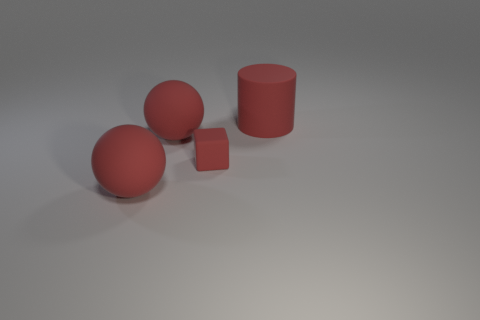Is the number of big red rubber things to the left of the small object greater than the number of red objects that are behind the large rubber cylinder?
Ensure brevity in your answer.  Yes. How many other things are there of the same material as the red cube?
Provide a succinct answer. 3. Are the big red sphere behind the tiny rubber thing and the cube made of the same material?
Your response must be concise. Yes. What is the shape of the small object?
Your response must be concise. Cube. Are there more tiny red blocks behind the tiny red matte object than big red rubber objects?
Ensure brevity in your answer.  No. Is there anything else that is the same shape as the small thing?
Provide a short and direct response. No. What is the shape of the big red rubber object that is to the right of the block?
Your answer should be very brief. Cylinder. There is a cylinder; are there any large matte balls right of it?
Provide a short and direct response. No. Is there anything else that is the same size as the cube?
Make the answer very short. No. There is a tiny cube that is made of the same material as the red cylinder; what color is it?
Your answer should be compact. Red. 